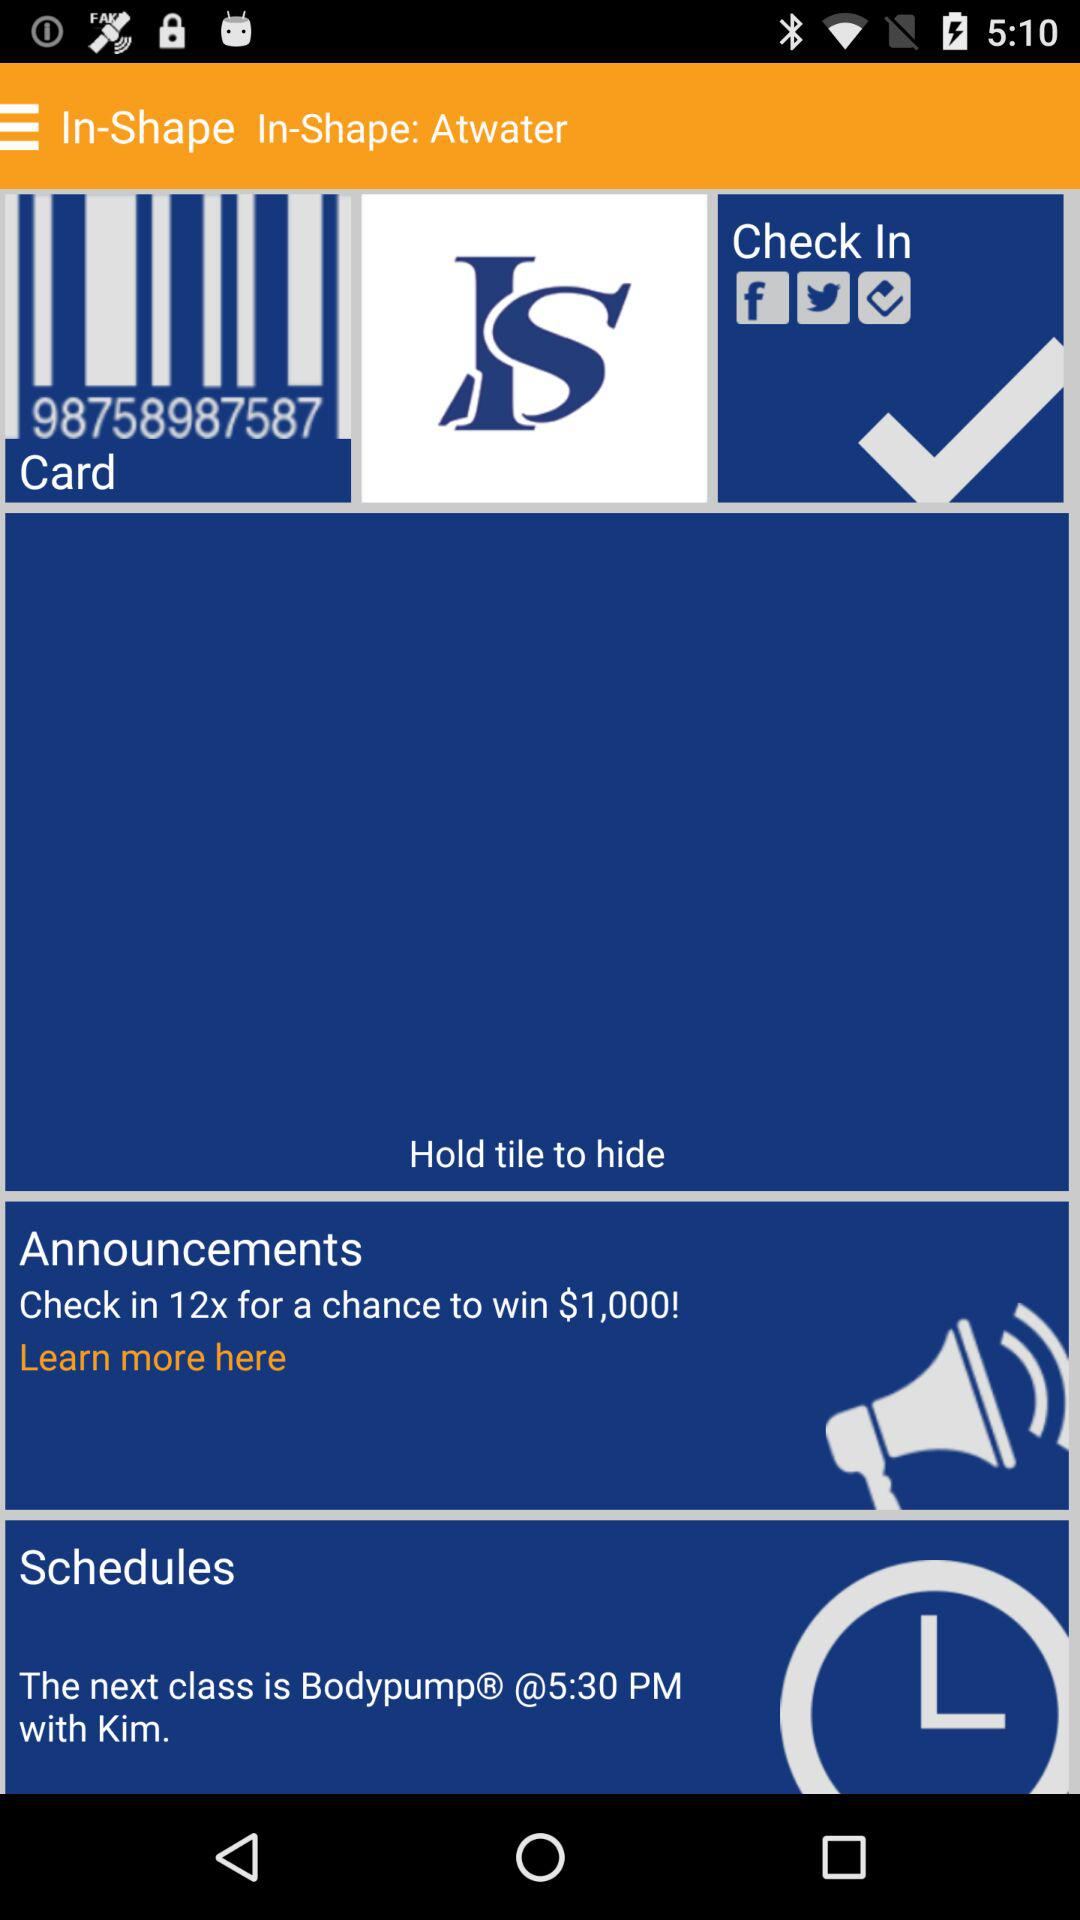What are the timings for the next class? The next class is at 5:30 PM. 